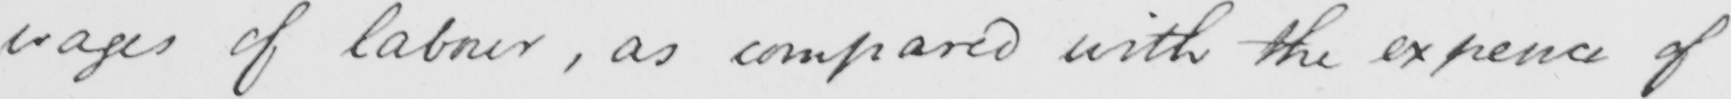What text is written in this handwritten line? wages of labour , as compared with the expence of 